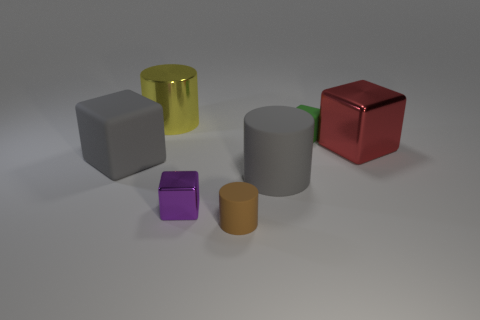Add 3 large brown metal balls. How many objects exist? 10 Subtract all large matte cylinders. How many cylinders are left? 2 Subtract all brown cylinders. How many cylinders are left? 2 Subtract all blocks. How many objects are left? 3 Subtract 1 cylinders. How many cylinders are left? 2 Subtract all purple cylinders. Subtract all red cubes. How many cylinders are left? 3 Subtract all red spheres. How many purple cubes are left? 1 Subtract all yellow metallic things. Subtract all tiny brown rubber things. How many objects are left? 5 Add 1 tiny purple shiny things. How many tiny purple shiny things are left? 2 Add 7 big gray spheres. How many big gray spheres exist? 7 